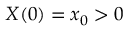<formula> <loc_0><loc_0><loc_500><loc_500>X ( 0 ) = x _ { 0 } > 0</formula> 